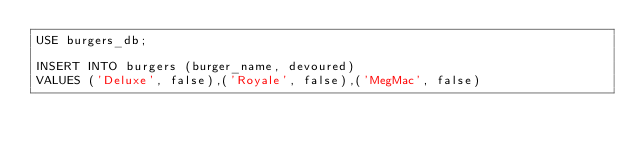<code> <loc_0><loc_0><loc_500><loc_500><_SQL_>USE burgers_db;

INSERT INTO burgers (burger_name, devoured) 
VALUES ('Deluxe', false),('Royale', false),('MegMac', false)</code> 